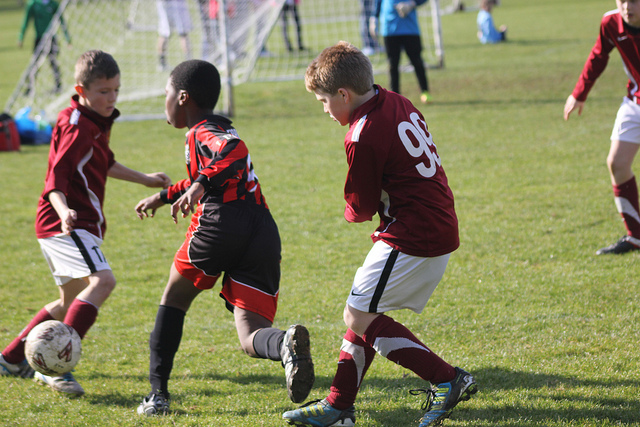Please transcribe the text information in this image. 99 